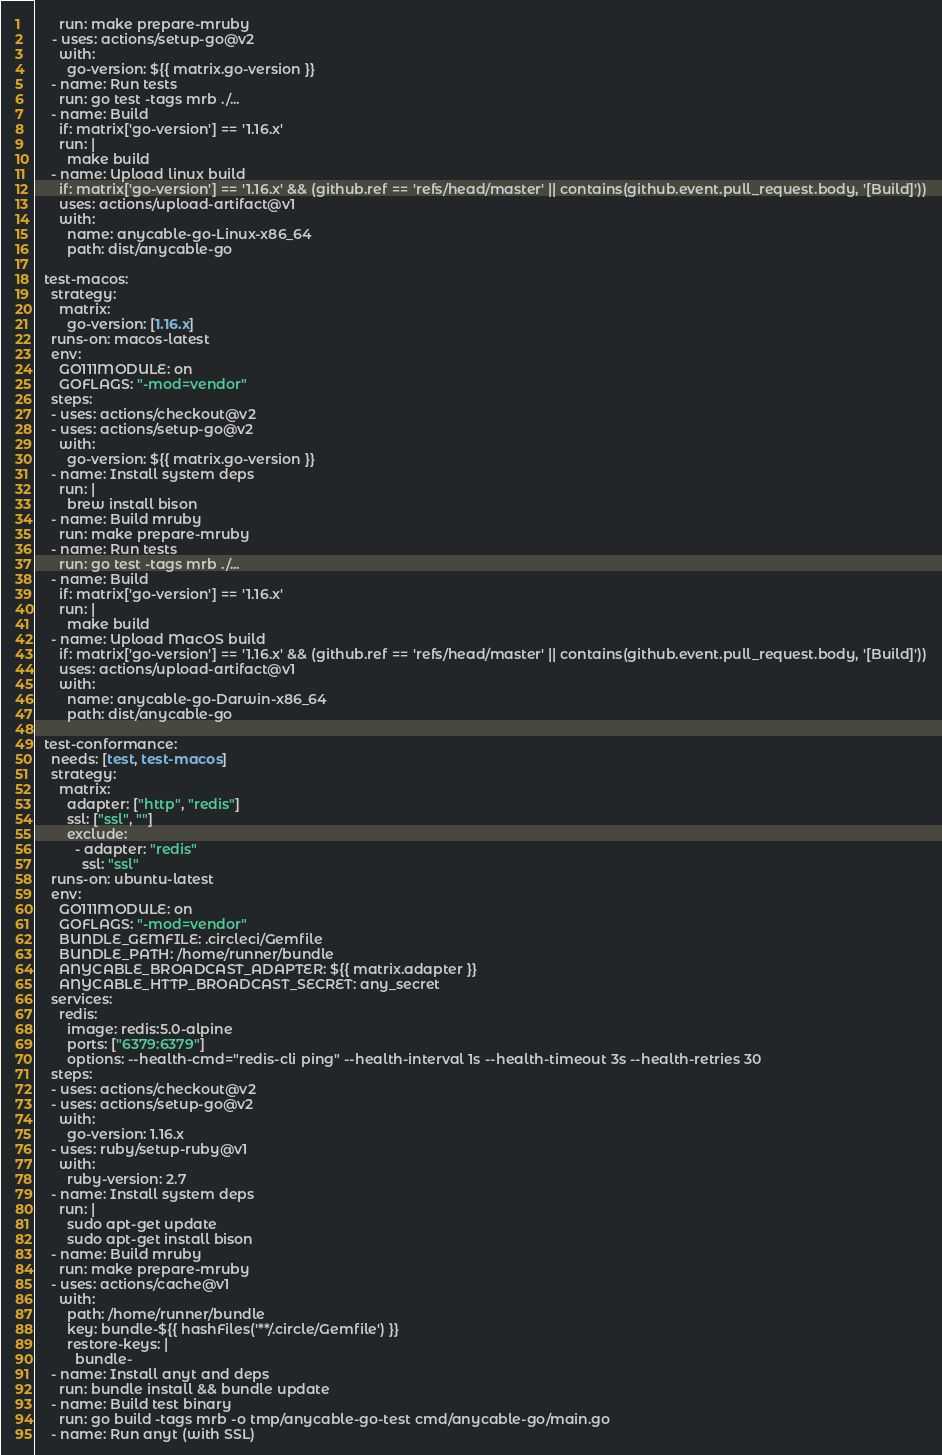Convert code to text. <code><loc_0><loc_0><loc_500><loc_500><_YAML_>      run: make prepare-mruby
    - uses: actions/setup-go@v2
      with:
        go-version: ${{ matrix.go-version }}
    - name: Run tests
      run: go test -tags mrb ./...
    - name: Build
      if: matrix['go-version'] == '1.16.x'
      run: |
        make build
    - name: Upload linux build
      if: matrix['go-version'] == '1.16.x' && (github.ref == 'refs/head/master' || contains(github.event.pull_request.body, '[Build]'))
      uses: actions/upload-artifact@v1
      with:
        name: anycable-go-Linux-x86_64
        path: dist/anycable-go

  test-macos:
    strategy:
      matrix:
        go-version: [1.16.x]
    runs-on: macos-latest
    env:
      GO111MODULE: on
      GOFLAGS: "-mod=vendor"
    steps:
    - uses: actions/checkout@v2
    - uses: actions/setup-go@v2
      with:
        go-version: ${{ matrix.go-version }}
    - name: Install system deps
      run: |
        brew install bison
    - name: Build mruby
      run: make prepare-mruby
    - name: Run tests
      run: go test -tags mrb ./...
    - name: Build
      if: matrix['go-version'] == '1.16.x'
      run: |
        make build
    - name: Upload MacOS build
      if: matrix['go-version'] == '1.16.x' && (github.ref == 'refs/head/master' || contains(github.event.pull_request.body, '[Build]'))
      uses: actions/upload-artifact@v1
      with:
        name: anycable-go-Darwin-x86_64
        path: dist/anycable-go

  test-conformance:
    needs: [test, test-macos]
    strategy:
      matrix:
        adapter: ["http", "redis"]
        ssl: ["ssl", ""]
        exclude:
          - adapter: "redis"
            ssl: "ssl"
    runs-on: ubuntu-latest
    env:
      GO111MODULE: on
      GOFLAGS: "-mod=vendor"
      BUNDLE_GEMFILE: .circleci/Gemfile
      BUNDLE_PATH: /home/runner/bundle
      ANYCABLE_BROADCAST_ADAPTER: ${{ matrix.adapter }}
      ANYCABLE_HTTP_BROADCAST_SECRET: any_secret
    services:
      redis:
        image: redis:5.0-alpine
        ports: ["6379:6379"]
        options: --health-cmd="redis-cli ping" --health-interval 1s --health-timeout 3s --health-retries 30
    steps:
    - uses: actions/checkout@v2
    - uses: actions/setup-go@v2
      with:
        go-version: 1.16.x
    - uses: ruby/setup-ruby@v1
      with:
        ruby-version: 2.7
    - name: Install system deps
      run: |
        sudo apt-get update
        sudo apt-get install bison
    - name: Build mruby
      run: make prepare-mruby
    - uses: actions/cache@v1
      with:
        path: /home/runner/bundle
        key: bundle-${{ hashFiles('**/.circle/Gemfile') }}
        restore-keys: |
          bundle-
    - name: Install anyt and deps
      run: bundle install && bundle update
    - name: Build test binary
      run: go build -tags mrb -o tmp/anycable-go-test cmd/anycable-go/main.go
    - name: Run anyt (with SSL)</code> 